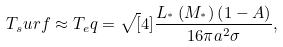<formula> <loc_0><loc_0><loc_500><loc_500>T _ { s } u r f \approx T _ { e } q = \sqrt { [ } 4 ] { \frac { L _ { ^ { * } } \left ( M _ { ^ { * } } \right ) \left ( 1 - A \right ) } { 1 6 \pi a ^ { 2 } \sigma } } ,</formula> 